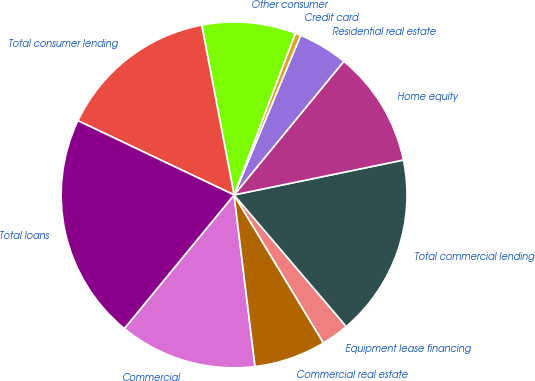Convert chart. <chart><loc_0><loc_0><loc_500><loc_500><pie_chart><fcel>Commercial<fcel>Commercial real estate<fcel>Equipment lease financing<fcel>Total commercial lending<fcel>Home equity<fcel>Residential real estate<fcel>Credit card<fcel>Other consumer<fcel>Total consumer lending<fcel>Total loans<nl><fcel>12.88%<fcel>6.71%<fcel>2.59%<fcel>17.0%<fcel>10.82%<fcel>4.65%<fcel>0.53%<fcel>8.76%<fcel>14.94%<fcel>21.12%<nl></chart> 